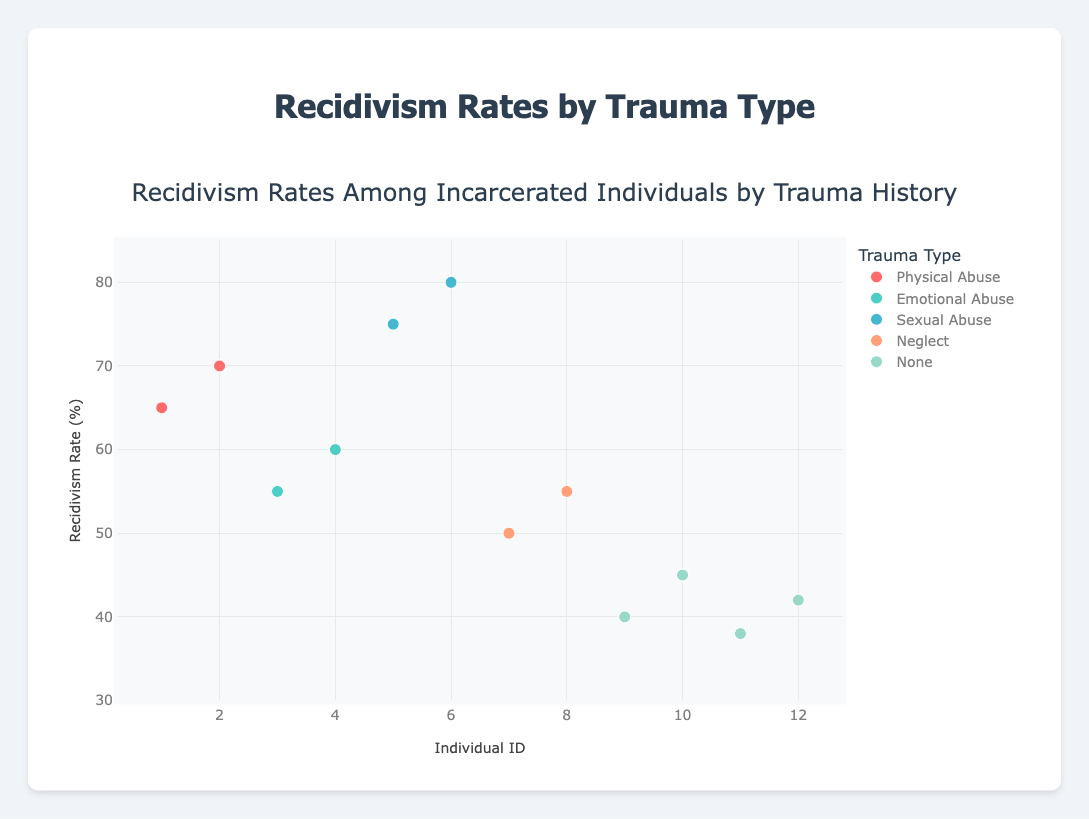What is the title of the plot? The title of the plot is clearly mentioned at the top of the figure.
Answer: Recidivism Rates Among Incarcerated Individuals by Trauma History What does the y-axis represent in the figure? The y-axis label indicates that it represents the Recidivism Rate (%) of the individuals.
Answer: Recidivism Rate (%) How many trauma types are categorized in the plot? By examining the legend, we can count the unique trauma types represented.
Answer: Five Which trauma type shows the highest recidivism rate? By comparing the highest data points across different trauma types, it is clear that the highest rate belongs to Sexual Abuse.
Answer: Sexual Abuse Which individual has the highest recidivism rate? Looking at the scatter plot and identifying the highest point on the y-axis across all trauma types helps determine that the highest rate belongs to the individual with a recidivism rate of 80%.
Answer: Individual with Trauma Type "Sexual Abuse" Compare the average recidivism rates for individuals with Sexual Abuse and those with no trauma history. To find the average, sum the recidivism rates and divide by the number of data points for each trauma type. For Sexual Abuse: (75 + 80)/2 = 77.5, and for None: (40 + 45 + 38 + 42)/4 = 41.25.
Answer: Sexual Abuse has higher average at 77.5 compared to None at 41.25 What is the difference in recidivism rates between the highest individual from Physical Abuse and the highest individual from Emotional Abuse? Identify the highest recidivism rate for each category: 70% for Physical Abuse and 60% for Emotional Abuse. Compute the difference: 70 - 60 = 10.
Answer: 10% Among all trauma types, which has the lowest recidivism rate? By looking for the lowest point on the y-axis across all trauma type groups, we find that the lowest rate is for “None”.
Answer: None How does the variability in recidivism rates compare between Physical Abuse and Neglect? Examine the spread of data points. Physical Abuse ranges from 65-70 while Neglect ranges from 50-55. Both show a range of 5%, but on different levels.
Answer: Similar variability (5%) but different ranges 